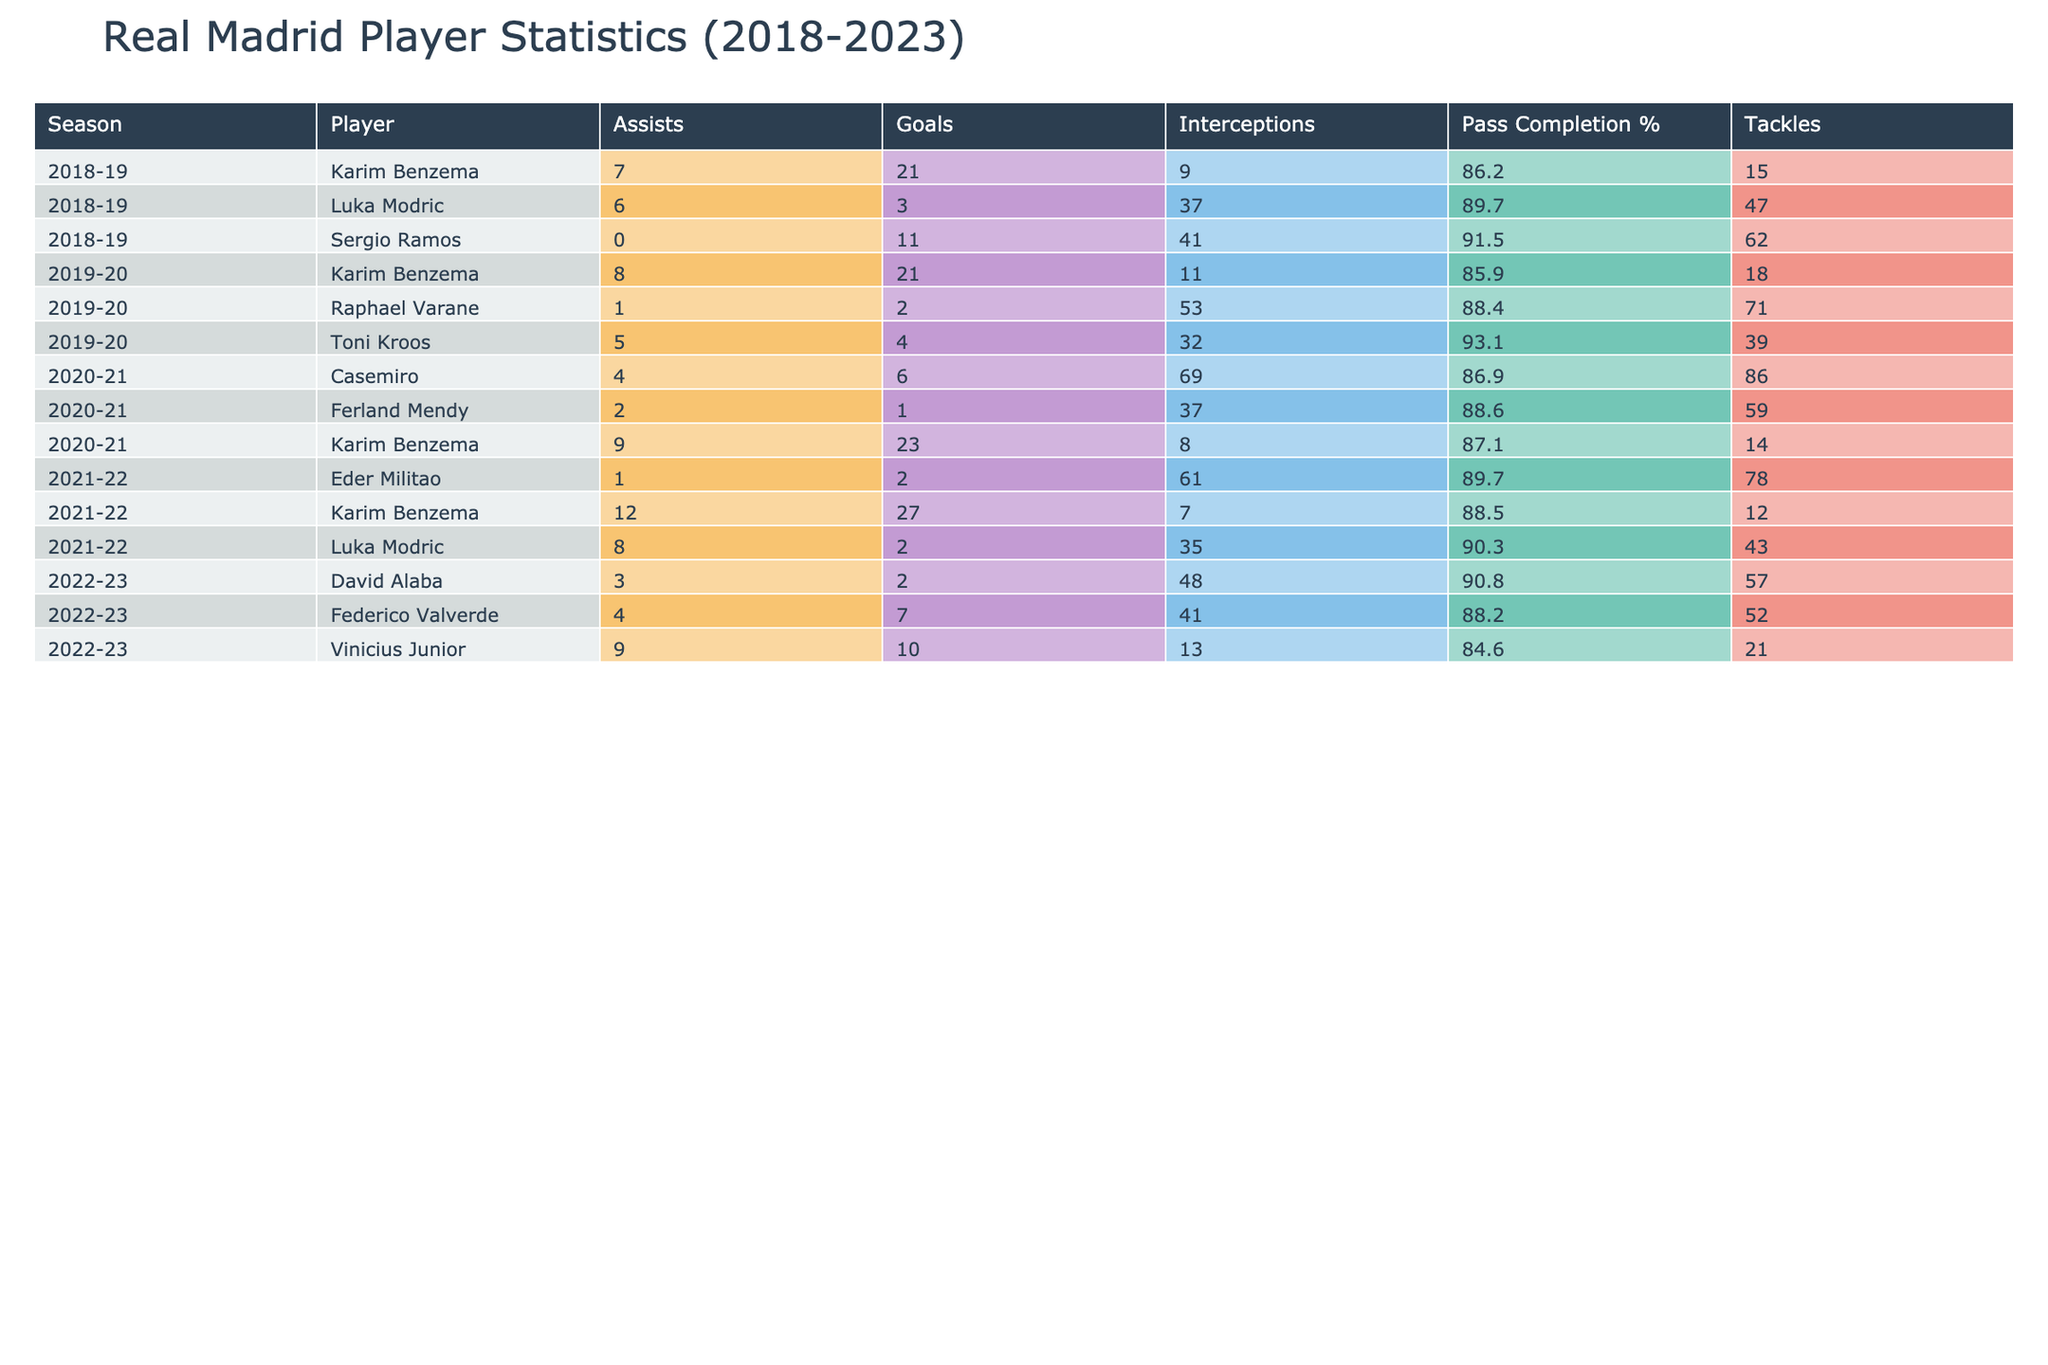What was Karim Benzema's total goal count over the 2018-2023 seasons? To find Benzema's total goals, we look at the "Goals" column for each season he played: 2018-19 has 21 goals, 2019-20 has 21 goals, 2020-21 has 23 goals, 2021-22 has 27 goals, and 2022-23 has 10 goals. Summing these gives 21 + 21 + 23 + 27 + 10 = 102 goals.
Answer: 102 Which season had the highest average pass completion percentage among players? We can identify the average pass completion percentage for each season. The values are: 2018-19: (86.2 + 89.7 + 91.5) / 3 = 89.1, 2019-20: (85.9 + 93.1 + 88.4) / 3 = 89.1, 2020-21: (87.1 + 86.9 + 88.6) / 3 = 87.9, 2021-22: (88.5 + 90.3 + 89.7) / 3 = 89.5, 2022-23: (84.6 + 88.2 + 90.8) / 3 = 87.8. The highest average is 89.5 in the 2021-22 season.
Answer: 2021-22 Did Sergio Ramos receive any red cards during the 2018-19 season? By examining the data for Sergio Ramos in the 2018-19 season, we check the "Red Cards" column. It shows he received 1 red card. Therefore, the answer is yes.
Answer: Yes Which defender had the most tackles in a single season from 2018-2023? We need to review the "Tackles" column for each defender across seasons. The values are: Ramos in 2018-19: 62, Varane in 2019-20: 71, Mendy in 2020-21: 59, Militao in 2021-22: 78, Alaba in 2022-23: 57. The highest is Militao with 78 tackles in the 2021-22 season.
Answer: Eder Militao (2021-22 season) What was the difference in goals scored by Karim Benzema between the 2020-21 season and the 2022-23 season? Benzema scored 23 goals in the 2020-21 season and 10 in the 2022-23 season. The difference is calculated as 23 - 10 = 13 goals.
Answer: 13 